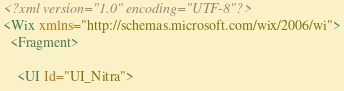<code> <loc_0><loc_0><loc_500><loc_500><_XML_><?xml version="1.0" encoding="UTF-8"?>
<Wix xmlns="http://schemas.microsoft.com/wix/2006/wi">
  <Fragment>

    <UI Id="UI_Nitra"></code> 